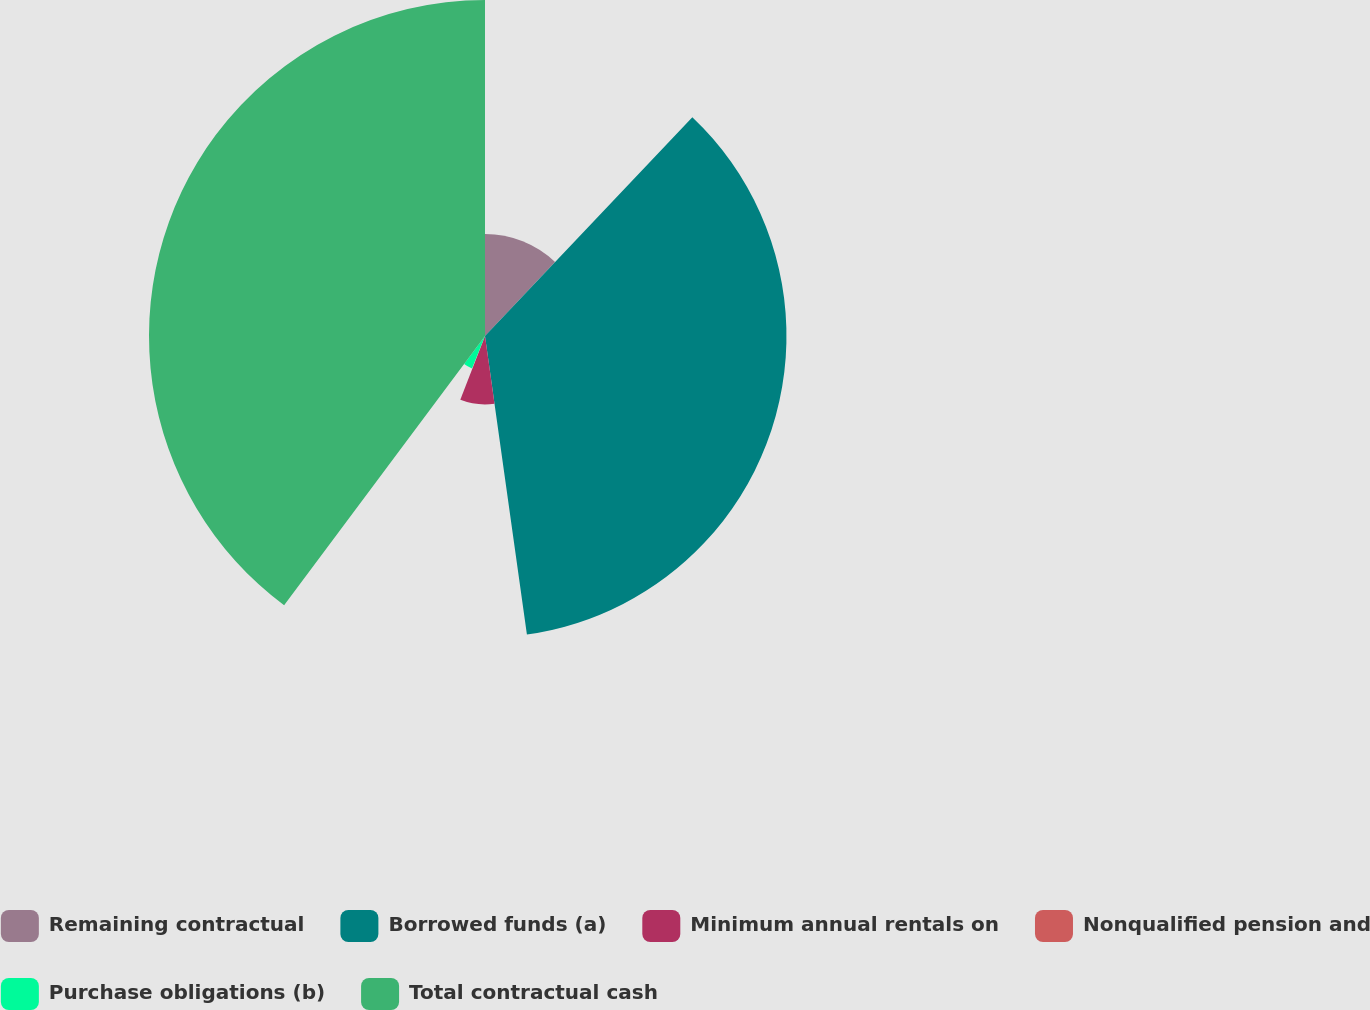<chart> <loc_0><loc_0><loc_500><loc_500><pie_chart><fcel>Remaining contractual<fcel>Borrowed funds (a)<fcel>Minimum annual rentals on<fcel>Nonqualified pension and<fcel>Purchase obligations (b)<fcel>Total contractual cash<nl><fcel>12.07%<fcel>35.71%<fcel>8.1%<fcel>0.18%<fcel>4.14%<fcel>39.8%<nl></chart> 